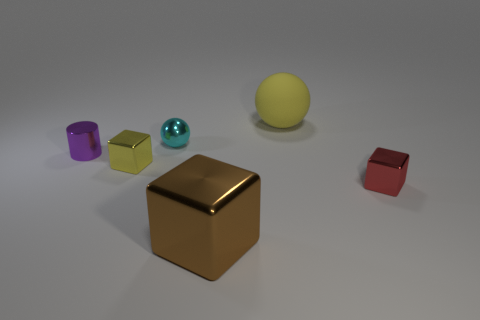How many large objects are both in front of the small cyan object and behind the tiny cylinder?
Provide a short and direct response. 0. Do the metallic sphere and the matte ball have the same color?
Provide a short and direct response. No. There is a large yellow thing that is the same shape as the cyan shiny object; what is its material?
Your answer should be very brief. Rubber. Is there any other thing that has the same material as the small yellow block?
Your response must be concise. Yes. Is the number of red blocks left of the small yellow block the same as the number of cubes behind the large yellow object?
Provide a short and direct response. Yes. Is the material of the red block the same as the big block?
Your answer should be very brief. Yes. How many brown objects are small matte spheres or matte balls?
Provide a short and direct response. 0. How many yellow objects have the same shape as the red thing?
Make the answer very short. 1. What is the tiny cyan thing made of?
Provide a succinct answer. Metal. Is the number of things behind the large brown metallic cube the same as the number of big green blocks?
Your answer should be compact. No. 